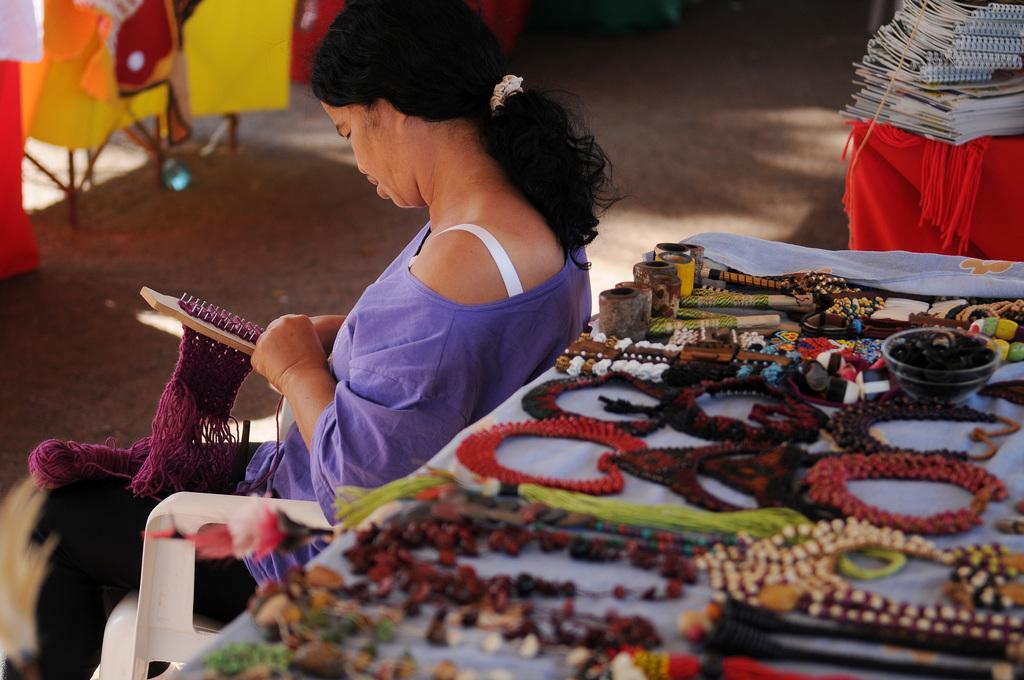Could you give a brief overview of what you see in this image? In this image we can see a woman sitting on the chair. In the background we can see the handmade chains and some other objects placed on the table. We can also see some books. Ground is also visible. 